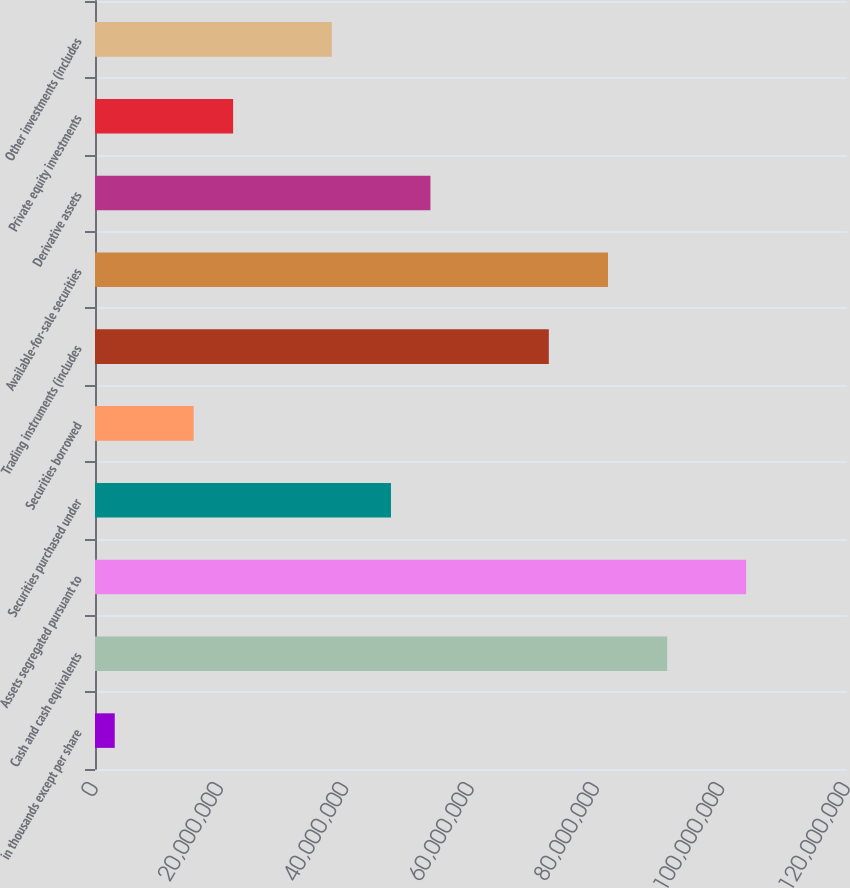Convert chart to OTSL. <chart><loc_0><loc_0><loc_500><loc_500><bar_chart><fcel>in thousands except per share<fcel>Cash and cash equivalents<fcel>Assets segregated pursuant to<fcel>Securities purchased under<fcel>Securities borrowed<fcel>Trading instruments (includes<fcel>Available-for-sale securities<fcel>Derivative assets<fcel>Private equity investments<fcel>Other investments (includes<nl><fcel>3.15006e+06<fcel>9.13094e+07<fcel>1.03904e+08<fcel>4.72297e+07<fcel>1.57442e+07<fcel>7.24181e+07<fcel>8.18637e+07<fcel>5.35268e+07<fcel>2.20413e+07<fcel>3.77841e+07<nl></chart> 